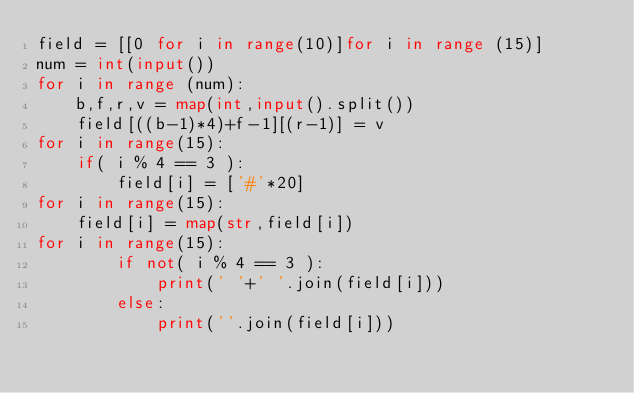Convert code to text. <code><loc_0><loc_0><loc_500><loc_500><_Python_>field = [[0 for i in range(10)]for i in range (15)]
num = int(input())
for i in range (num):
	b,f,r,v = map(int,input().split())
	field[((b-1)*4)+f-1][(r-1)] = v
for i in range(15):
	if( i % 4 == 3 ):
 		field[i] = ['#'*20]
for i in range(15):
	field[i] = map(str,field[i])
for i in range(15):
		if not( i % 4 == 3 ):
			print(' '+' '.join(field[i]))
		else:
			print(''.join(field[i]))
</code> 